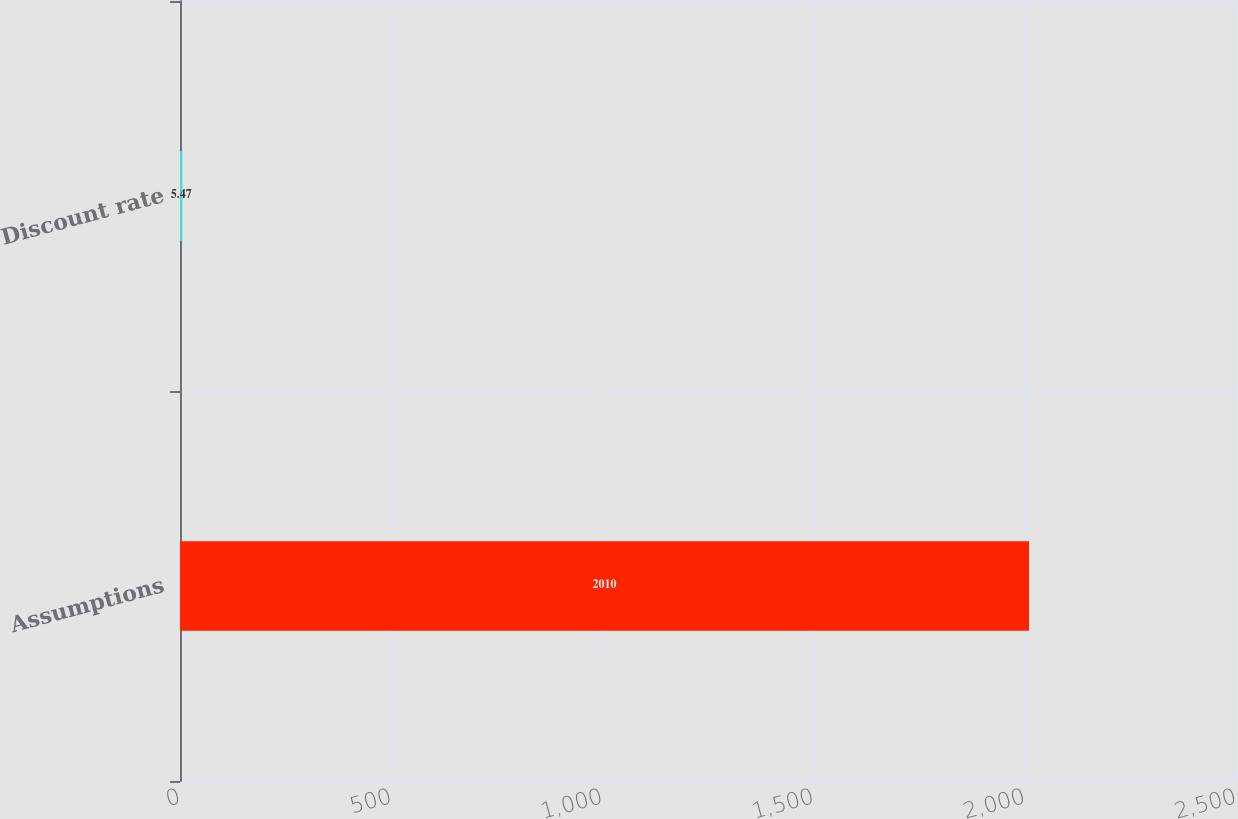Convert chart to OTSL. <chart><loc_0><loc_0><loc_500><loc_500><bar_chart><fcel>Assumptions<fcel>Discount rate<nl><fcel>2010<fcel>5.47<nl></chart> 